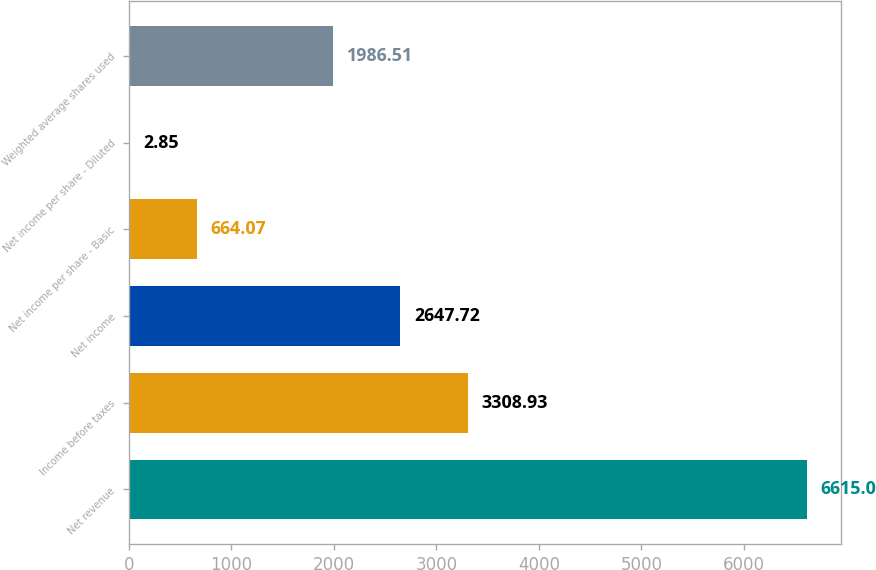Convert chart to OTSL. <chart><loc_0><loc_0><loc_500><loc_500><bar_chart><fcel>Net revenue<fcel>Income before taxes<fcel>Net income<fcel>Net income per share - Basic<fcel>Net income per share - Diluted<fcel>Weighted average shares used<nl><fcel>6615<fcel>3308.93<fcel>2647.72<fcel>664.07<fcel>2.85<fcel>1986.51<nl></chart> 